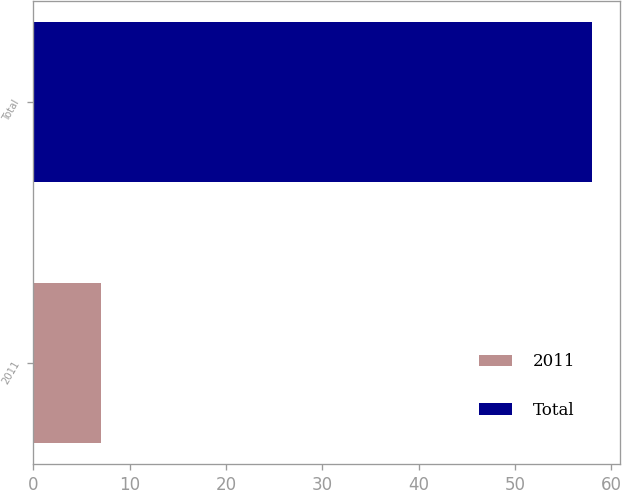Convert chart to OTSL. <chart><loc_0><loc_0><loc_500><loc_500><bar_chart><fcel>2011<fcel>Total<nl><fcel>7<fcel>58<nl></chart> 